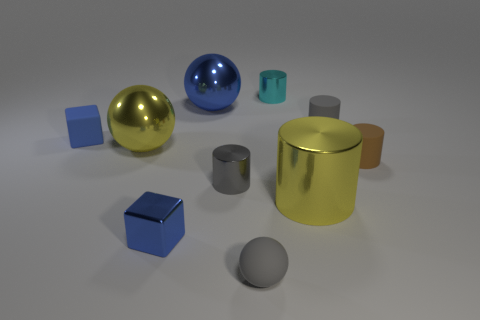What size is the thing that is to the right of the small metallic cube and in front of the large yellow cylinder?
Your response must be concise. Small. There is a cyan shiny object; is it the same shape as the yellow shiny object behind the small brown matte cylinder?
Offer a very short reply. No. There is a rubber object that is the same shape as the big blue shiny thing; what is its size?
Ensure brevity in your answer.  Small. There is a rubber block; is its color the same as the ball in front of the small blue shiny thing?
Make the answer very short. No. What number of other things are the same size as the metal block?
Keep it short and to the point. 6. What is the shape of the big metal thing behind the big yellow thing on the left side of the small gray rubber object that is left of the small cyan cylinder?
Give a very brief answer. Sphere. There is a yellow cylinder; is it the same size as the ball in front of the large yellow sphere?
Provide a succinct answer. No. There is a tiny rubber thing that is right of the cyan metal cylinder and behind the small brown matte cylinder; what color is it?
Ensure brevity in your answer.  Gray. What number of other objects are there of the same shape as the cyan thing?
Your answer should be very brief. 4. Do the big thing that is on the left side of the big blue metallic ball and the cylinder that is in front of the tiny gray metal cylinder have the same color?
Give a very brief answer. Yes. 